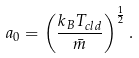<formula> <loc_0><loc_0><loc_500><loc_500>a _ { 0 } = \left ( \frac { k _ { B } T _ { c l d } } { \bar { m } } \right ) ^ { \frac { 1 } { 2 } } .</formula> 